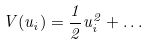Convert formula to latex. <formula><loc_0><loc_0><loc_500><loc_500>V ( u _ { i } ) = \frac { 1 } { 2 } u _ { i } ^ { 2 } + \dots</formula> 